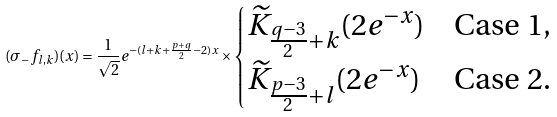<formula> <loc_0><loc_0><loc_500><loc_500>( \sigma _ { - } f _ { l , k } ) ( x ) = \frac { 1 } { \sqrt { 2 } } e ^ { - ( l + k + \frac { p + q } { 2 } - 2 ) x } \times \begin{cases} \widetilde { K } _ { \frac { q - 3 } { 2 } + k } ( 2 e ^ { - x } ) & \text {Case 1} , \\ \widetilde { K } _ { \frac { p - 3 } { 2 } + l } ( 2 e ^ { - x } ) & \text {Case 2} . \end{cases}</formula> 